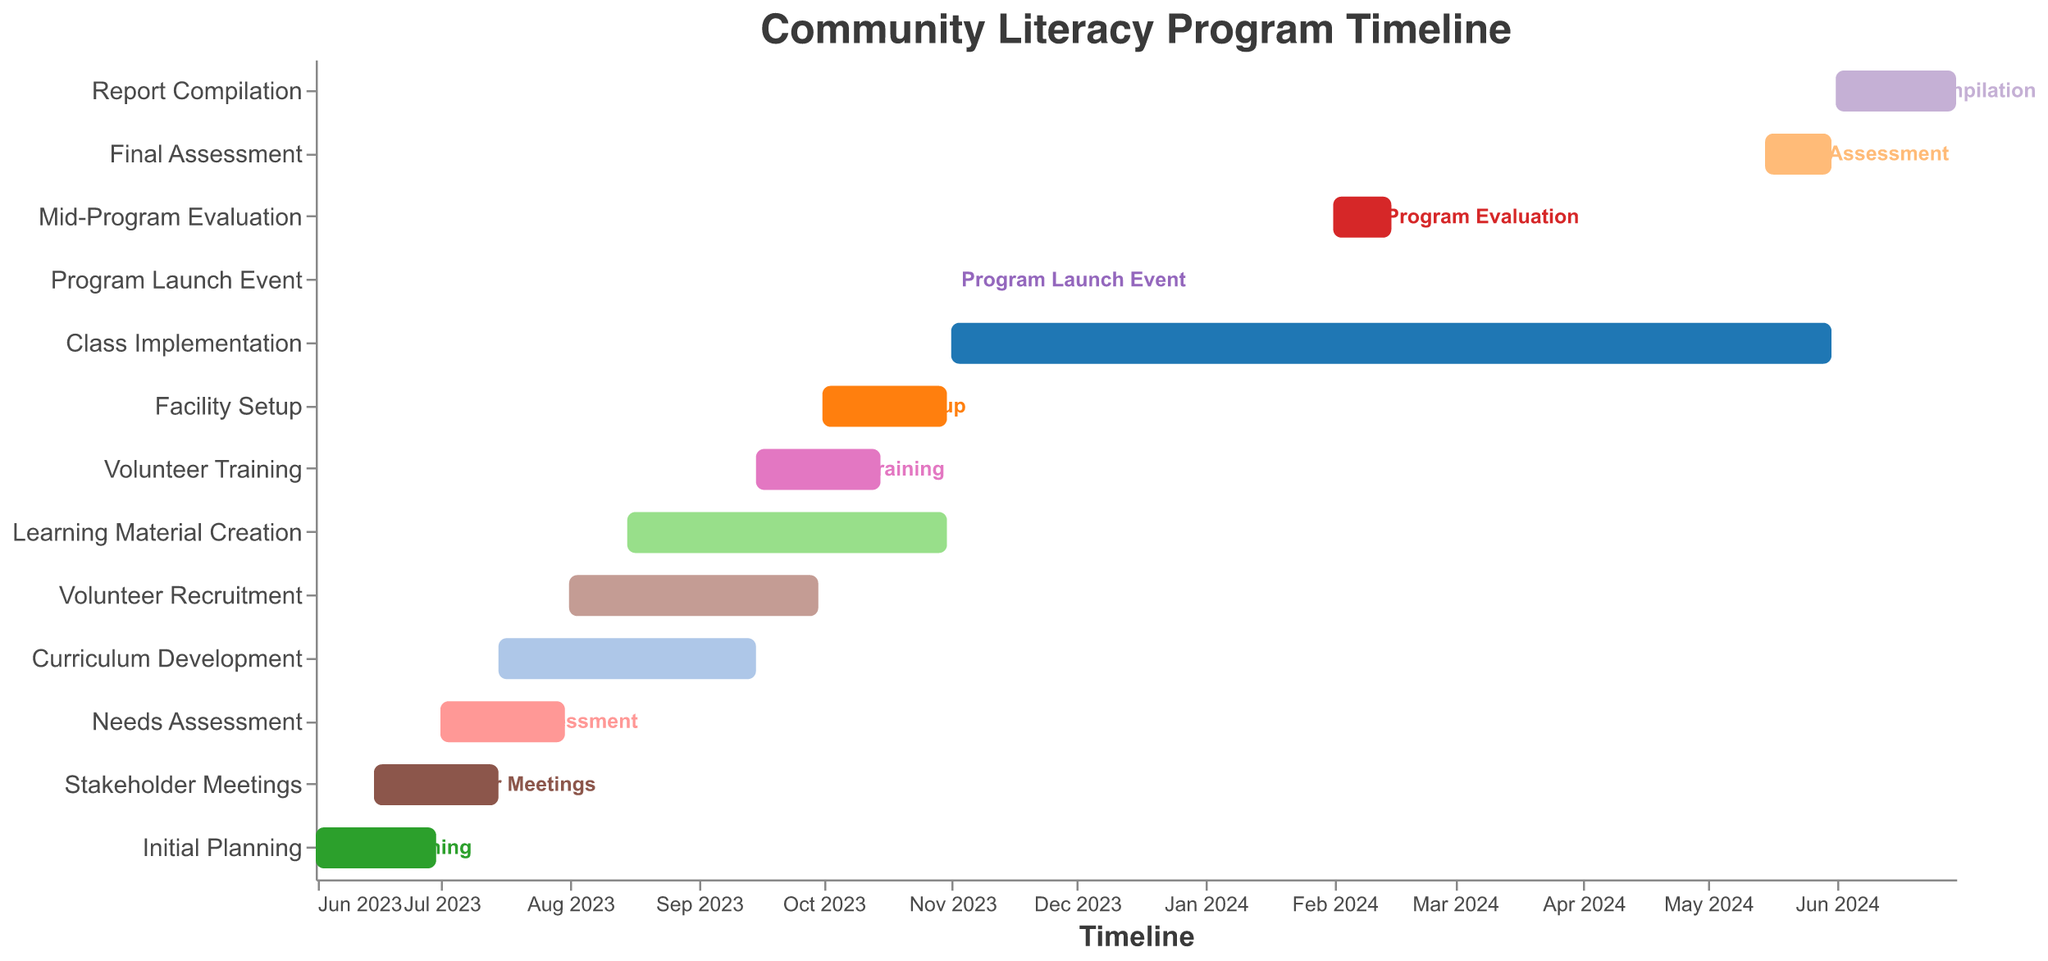What is the title of the figure? The title is usually at the top of the figure and indicates what the chart is about. In this case, the title is "Community Literacy Program Timeline" as specified in the figure code.
Answer: Community Literacy Program Timeline Which tasks start in August 2023? Look at the x-axis for August 2023 and see which bars start at this point. The tasks that start in August 2023 are "Volunteer Recruitment" and "Learning Material Creation".
Answer: Volunteer Recruitment, Learning Material Creation How long is the "Class Implementation" task scheduled to last? Find the "Class Implementation" task in the y-axis, then look at its start and end dates on the x-axis. This task runs from November 1, 2023, to May 31, 2024. Calculate the difference between these two dates.
Answer: Approximately 7 months Which task overlaps with "Volunteer Training"? Determine the duration of "Volunteer Training" (September 15, 2023, to October 15, 2023) and identify any other tasks that occur within this time frame. "Learning Material Creation" and "Facility Setup" overlap with "Volunteer Training".
Answer: Learning Material Creation, Facility Setup When does "Mid-Program Evaluation" take place? Find "Mid-Program Evaluation" on the y-axis and look at its corresponding dates on the x-axis. This task starts on February 1, 2024, and ends on February 15, 2024.
Answer: February 1 to February 15, 2024 Which tasks are completed by the end of September 2023? Check tasks that have end dates before or on September 30, 2023. Tasks completed by then include "Initial Planning," "Stakeholder Meetings," "Needs Assessment," "Curriculum Development," and "Volunteer Recruitment".
Answer: Initial Planning, Stakeholder Meetings, Needs Assessment, Curriculum Development, Volunteer Recruitment Compare the duration of "Facility Setup" and "Report Compilation." Which is longer? Find the start and end dates for both tasks. "Facility Setup" runs from October 1, 2023, to October 31, 2023, and "Report Compilation" runs from June 1, 2024, to June 30, 2024. Both tasks last for one month.
Answer: Both are equal When does the "Program Launch Event" occur? Locate the "Program Launch Event" task on the y-axis and check its corresponding timeline on the x-axis. It is set for November 1, 2023.
Answer: November 1, 2023 What is happening at the start of June 2023? Look at the timeline and match it with tasks starting at that time. The task starting in June 2023 is "Initial Planning".
Answer: Initial Planning Which tasks extend into 2024? Identify tasks that have end dates in 2024. These include "Class Implementation", "Mid-Program Evaluation", "Final Assessment", and "Report Compilation".
Answer: Class Implementation, Mid-Program Evaluation, Final Assessment, Report Compilation 